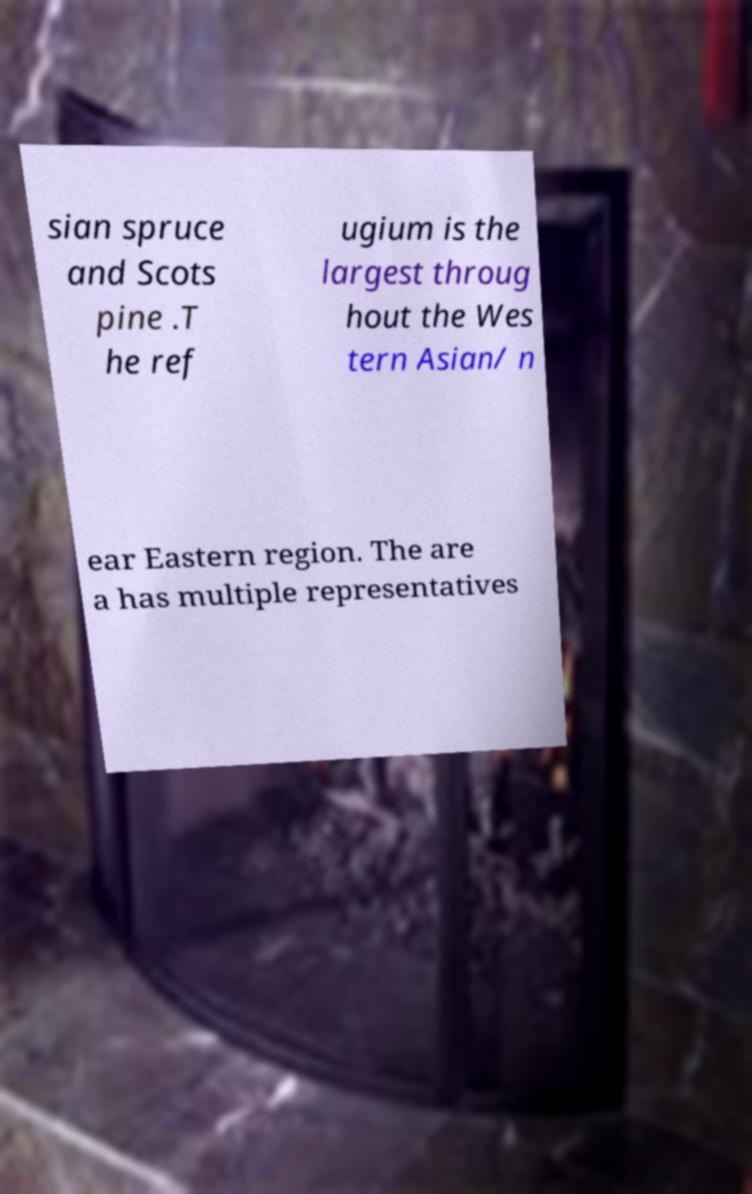Please identify and transcribe the text found in this image. sian spruce and Scots pine .T he ref ugium is the largest throug hout the Wes tern Asian/ n ear Eastern region. The are a has multiple representatives 